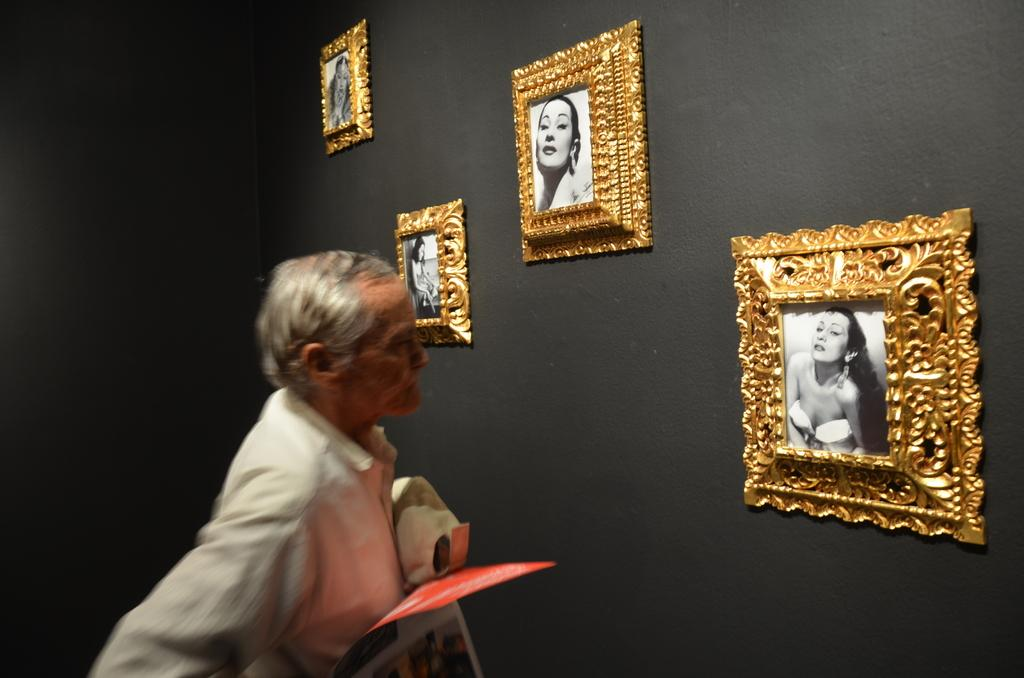What is the main subject of the image? There is a man standing in the image. What is the man holding in his hands? The man is holding an object in his hands. Can you describe the background of the image? There are photos on a black color wall in the image. What can be seen in the photos on the wall? The photos contain images of women. What type of rabbit can be seen hopping on the brick wall in the image? There is no rabbit or brick wall present in the image. Can you describe the teeth of the man in the image? The image does not show the man's teeth, so it cannot be determined from the image. 